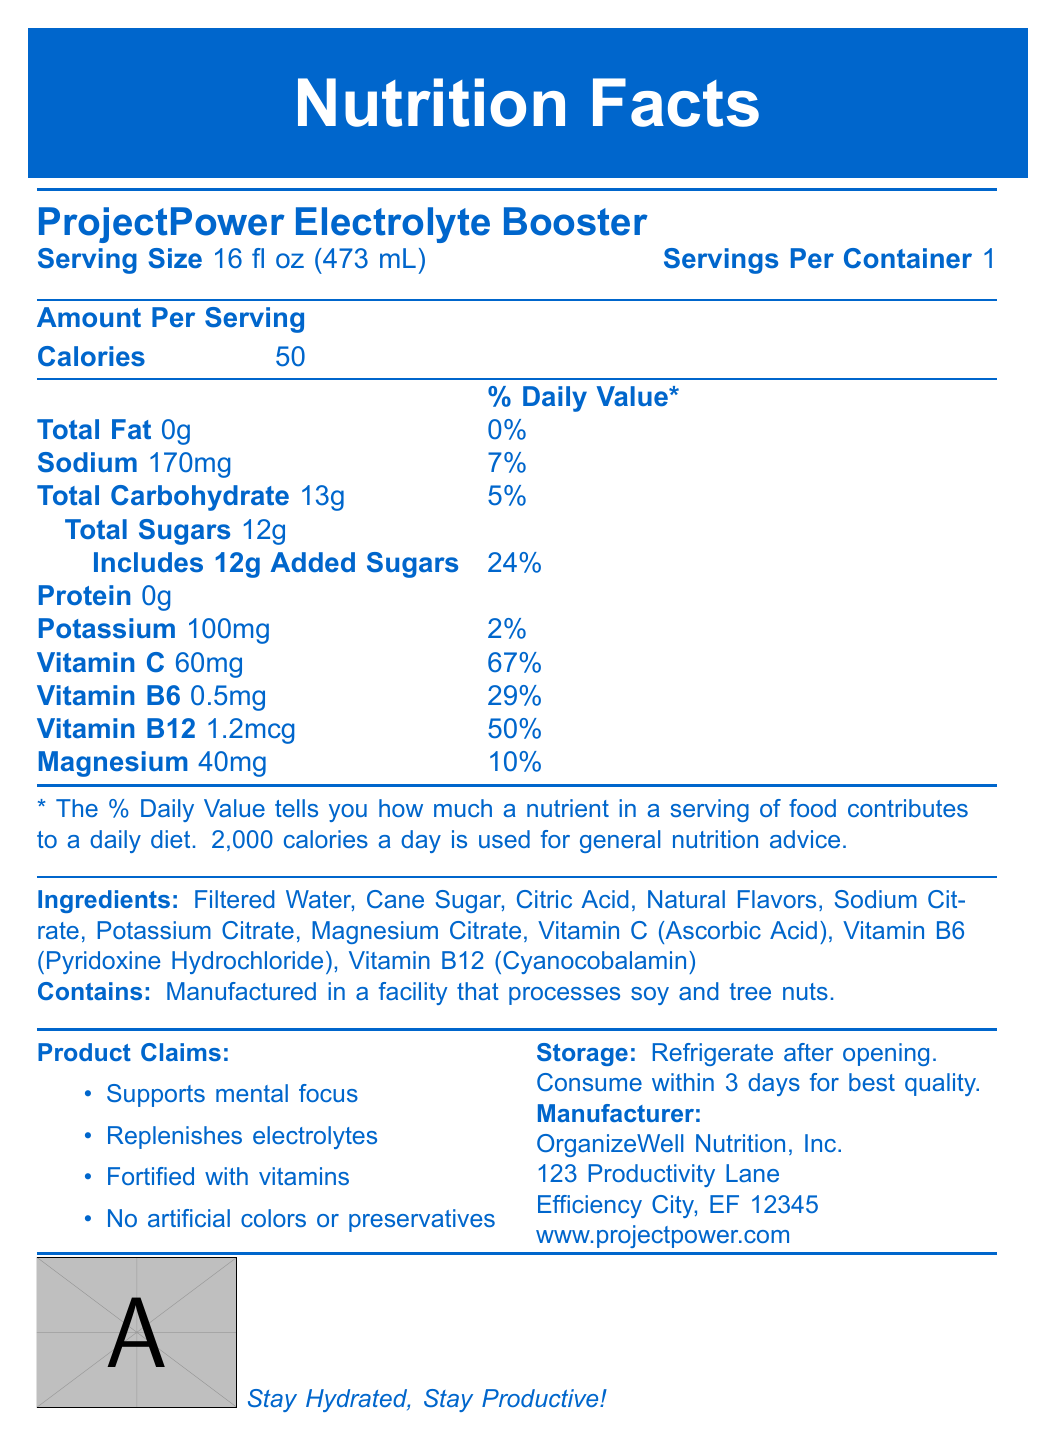what is the serving size of ProjectPower Electrolyte Booster? The serving size is specified at the beginning under the product name and nutritional information.
Answer: 16 fl oz (473 mL) how many calories are in one serving? The calorie count is listed under the "Amount Per Serving" section.
Answer: 50 calories what is the daily value percentage for sodium? The daily value percentage for sodium is listed next to the amount of 170mg.
Answer: 7% does the drink contain any protein? The document lists "Protein" with an amount of 0g, indicating the drink contains no protein.
Answer: No name one of the ingredients in ProjectPower Electrolyte Booster. The Ingredients section lists several ingredients, including Filtered Water.
Answer: Filtered Water which vitamin has the highest daily value percentage in this drink? A. Vitamin C B. Vitamin B6 C. Vitamin B12 The document shows Vitamin C with a daily value of 67%, which is higher than Vitamin B6 (29%) and Vitamin B12 (50%).
Answer: A. Vitamin C how many grams of total sugars are in the drink? A. 10g B. 12g C. 14g D. 13g The total sugars are listed as 12g under the "Total Sugars" section.
Answer: B. 12g does ProjectPower Electrolyte Booster contain any artificial colors or preservatives? The product claims clearly state "No artificial colors or preservatives."
Answer: No should the drink be refrigerated after opening? The storage instructions indicate that the drink should be refrigerated after opening.
Answer: Yes is there any information about allergens? The allergen information states that the product is manufactured in a facility that processes soy and tree nuts.
Answer: Yes summarize the main claims of ProjectPower Electrolyte Booster. The product claims section lists these key benefits to emphasize the drink's functions and ingredients.
Answer: Supports mental focus, Replenishes electrolytes, Fortified with vitamins, No artificial colors or preservatives what is the exact address of the manufacturer? The manufacturer information provides this address.
Answer: 123 Productivity Lane, Efficiency City, EF 12345 how much potassium does one serving contain? The amount of potassium is specifically listed in the nutritional information section.
Answer: 100mg what is the protein content per serving? The amount of protein per serving is clearly listed as 0g.
Answer: 0g who manufactures ProjectPower Electrolyte Booster? The manufacturer is indicated in the contact section at the end of the document.
Answer: OrganizeWell Nutrition, Inc. what website can you visit for more information? The contact information provides this website link.
Answer: www.projectpower.com is there information about how long to consume the drink after opening? The storage instructions mention consuming within 3 days for the best quality.
Answer: Yes what is not included in the nutrition facts label? The question is too general as the label contains extensive information about nutrients, ingredients, and claims, but without specifying a precise missing item, it is unclear.
Answer: Not enough information 